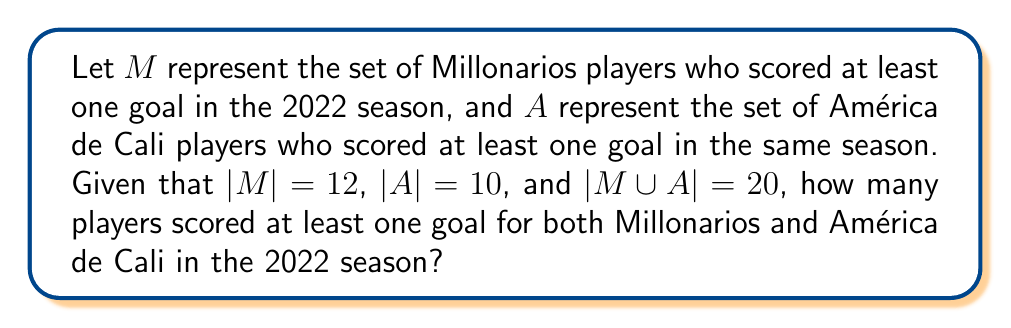Could you help me with this problem? To solve this problem, we'll use set theory concepts, specifically the principle of inclusion-exclusion.

1) Let $|M \cap A|$ be the number of players who scored for both teams.

2) The principle of inclusion-exclusion states:
   $|M \cup A| = |M| + |A| - |M \cap A|$

3) We're given:
   $|M \cup A| = 20$
   $|M| = 12$
   $|A| = 10$

4) Substituting these values into the formula:
   $20 = 12 + 10 - |M \cap A|$

5) Simplifying:
   $20 = 22 - |M \cap A|$

6) Subtracting 22 from both sides:
   $-2 = -|M \cap A|$

7) Multiplying both sides by -1:
   $2 = |M \cap A|$

Therefore, 2 players scored at least one goal for both Millonarios and América de Cali in the 2022 season.
Answer: 2 players 